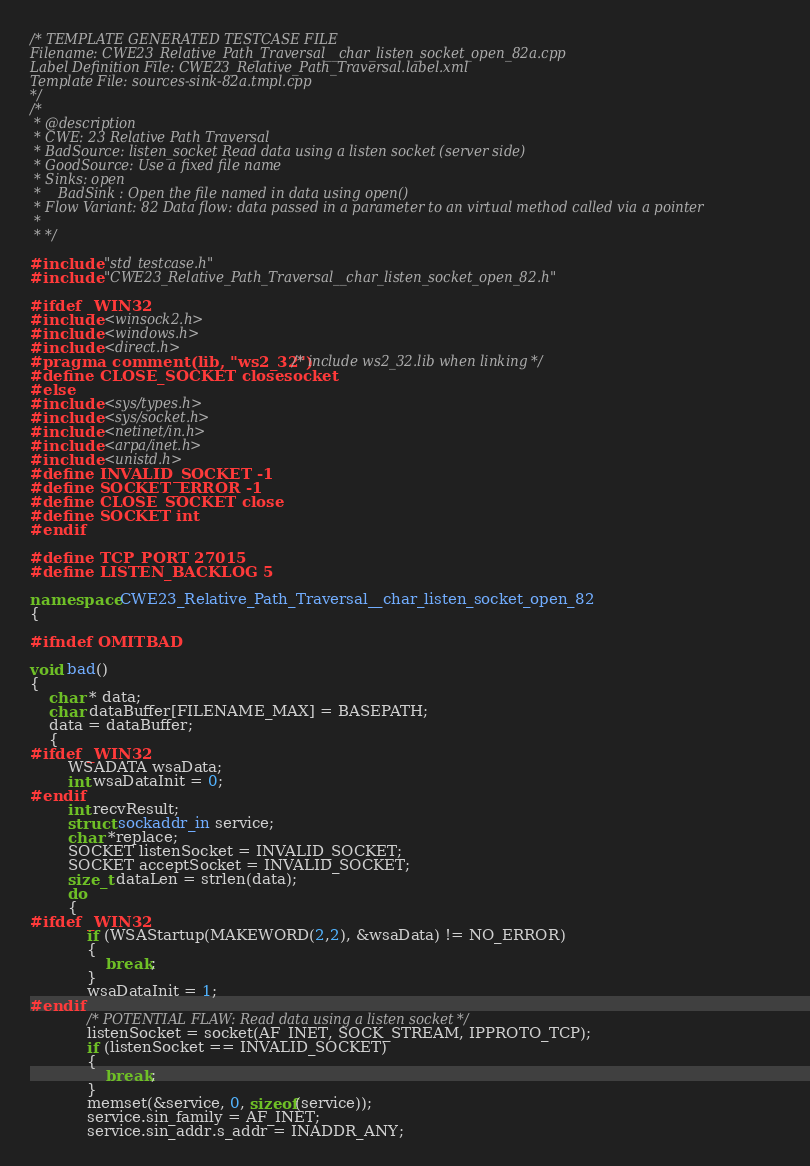Convert code to text. <code><loc_0><loc_0><loc_500><loc_500><_C++_>/* TEMPLATE GENERATED TESTCASE FILE
Filename: CWE23_Relative_Path_Traversal__char_listen_socket_open_82a.cpp
Label Definition File: CWE23_Relative_Path_Traversal.label.xml
Template File: sources-sink-82a.tmpl.cpp
*/
/*
 * @description
 * CWE: 23 Relative Path Traversal
 * BadSource: listen_socket Read data using a listen socket (server side)
 * GoodSource: Use a fixed file name
 * Sinks: open
 *    BadSink : Open the file named in data using open()
 * Flow Variant: 82 Data flow: data passed in a parameter to an virtual method called via a pointer
 *
 * */

#include "std_testcase.h"
#include "CWE23_Relative_Path_Traversal__char_listen_socket_open_82.h"

#ifdef _WIN32
#include <winsock2.h>
#include <windows.h>
#include <direct.h>
#pragma comment(lib, "ws2_32") /* include ws2_32.lib when linking */
#define CLOSE_SOCKET closesocket
#else
#include <sys/types.h>
#include <sys/socket.h>
#include <netinet/in.h>
#include <arpa/inet.h>
#include <unistd.h>
#define INVALID_SOCKET -1
#define SOCKET_ERROR -1
#define CLOSE_SOCKET close
#define SOCKET int
#endif

#define TCP_PORT 27015
#define LISTEN_BACKLOG 5

namespace CWE23_Relative_Path_Traversal__char_listen_socket_open_82
{

#ifndef OMITBAD

void bad()
{
    char * data;
    char dataBuffer[FILENAME_MAX] = BASEPATH;
    data = dataBuffer;
    {
#ifdef _WIN32
        WSADATA wsaData;
        int wsaDataInit = 0;
#endif
        int recvResult;
        struct sockaddr_in service;
        char *replace;
        SOCKET listenSocket = INVALID_SOCKET;
        SOCKET acceptSocket = INVALID_SOCKET;
        size_t dataLen = strlen(data);
        do
        {
#ifdef _WIN32
            if (WSAStartup(MAKEWORD(2,2), &wsaData) != NO_ERROR)
            {
                break;
            }
            wsaDataInit = 1;
#endif
            /* POTENTIAL FLAW: Read data using a listen socket */
            listenSocket = socket(AF_INET, SOCK_STREAM, IPPROTO_TCP);
            if (listenSocket == INVALID_SOCKET)
            {
                break;
            }
            memset(&service, 0, sizeof(service));
            service.sin_family = AF_INET;
            service.sin_addr.s_addr = INADDR_ANY;</code> 